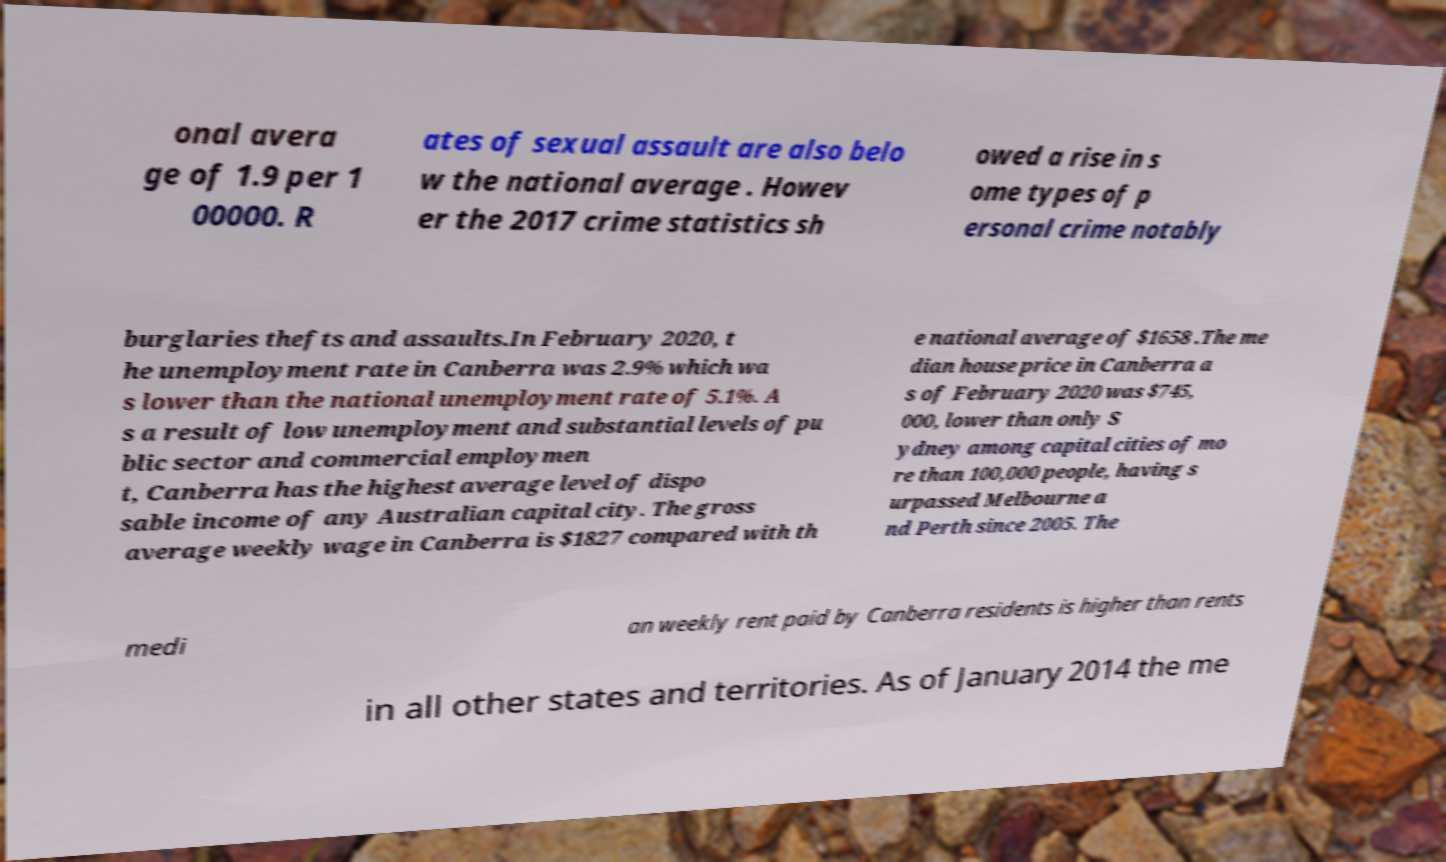For documentation purposes, I need the text within this image transcribed. Could you provide that? onal avera ge of 1.9 per 1 00000. R ates of sexual assault are also belo w the national average . Howev er the 2017 crime statistics sh owed a rise in s ome types of p ersonal crime notably burglaries thefts and assaults.In February 2020, t he unemployment rate in Canberra was 2.9% which wa s lower than the national unemployment rate of 5.1%. A s a result of low unemployment and substantial levels of pu blic sector and commercial employmen t, Canberra has the highest average level of dispo sable income of any Australian capital city. The gross average weekly wage in Canberra is $1827 compared with th e national average of $1658 .The me dian house price in Canberra a s of February 2020 was $745, 000, lower than only S ydney among capital cities of mo re than 100,000 people, having s urpassed Melbourne a nd Perth since 2005. The medi an weekly rent paid by Canberra residents is higher than rents in all other states and territories. As of January 2014 the me 